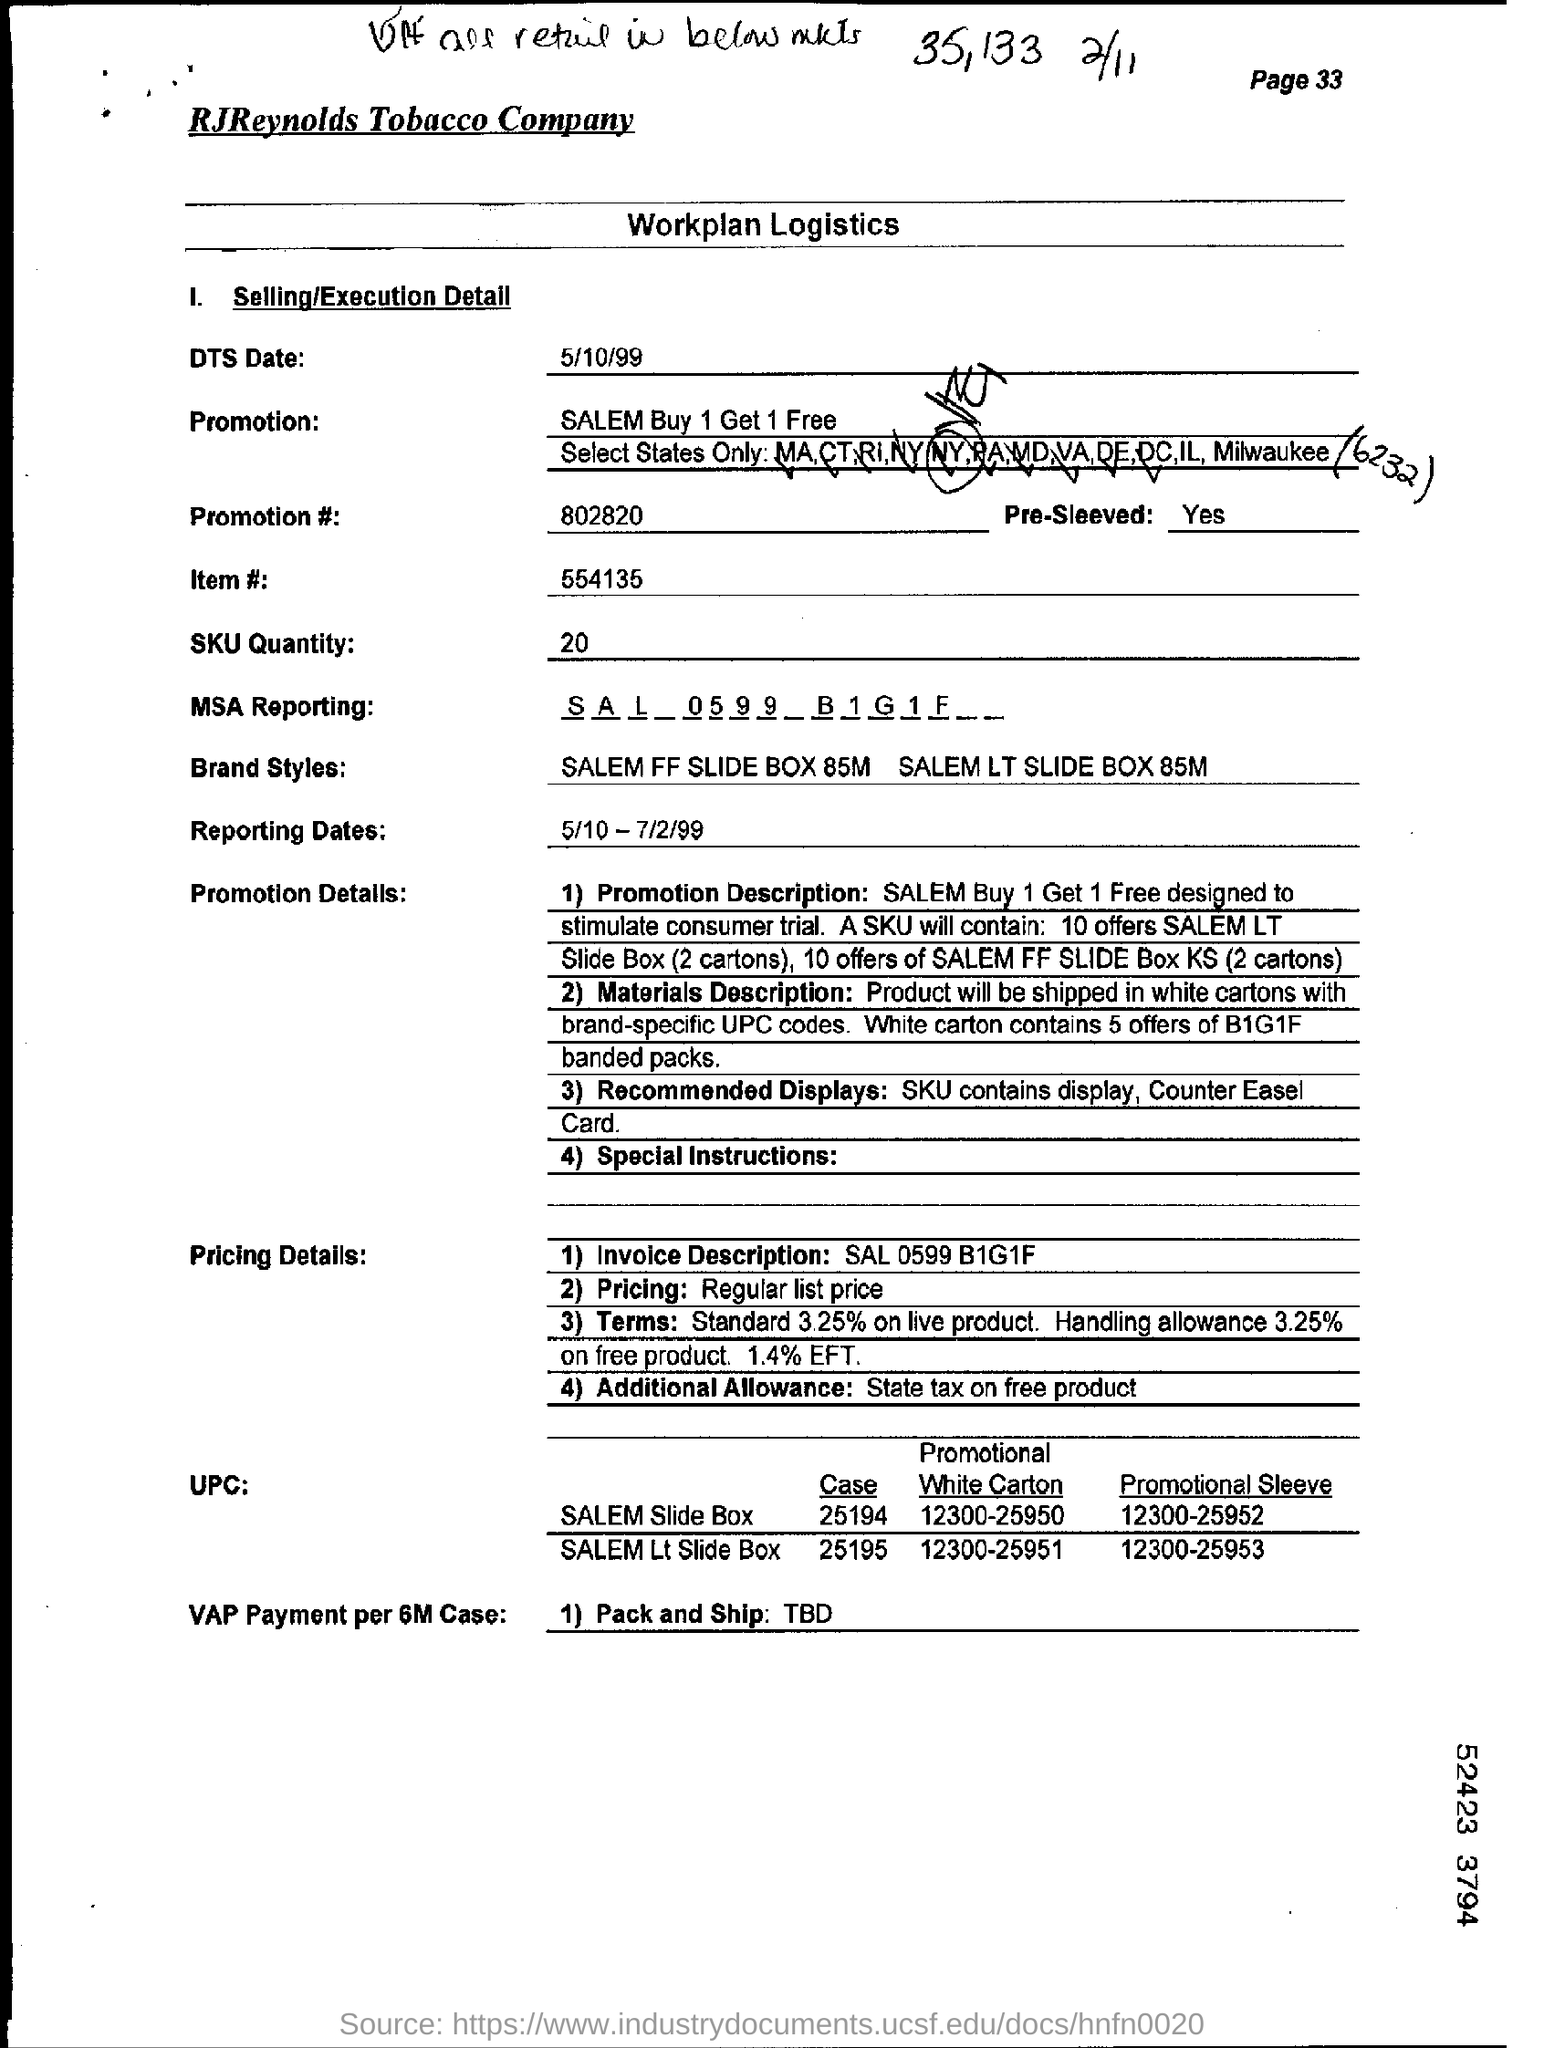Draw attention to some important aspects in this diagram. The name of the company is RJReynolds Tobacco Company. SKU quantity refers to the amount of a particular product that is available for purchase. The date mentioned in the DTS is May 10, 1999. SALEM is offering a buy one get one free deal on its products. 